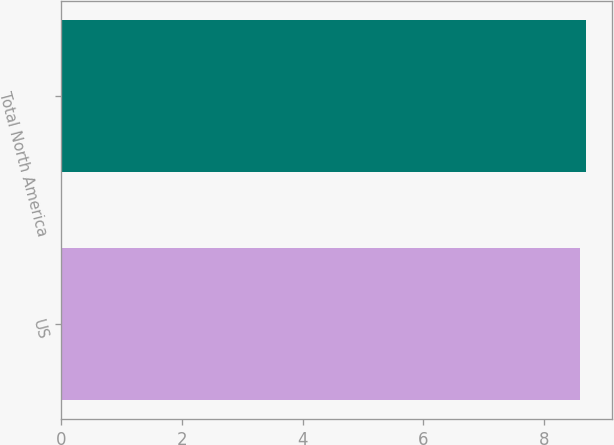<chart> <loc_0><loc_0><loc_500><loc_500><bar_chart><fcel>US<fcel>Total North America<nl><fcel>8.6<fcel>8.7<nl></chart> 